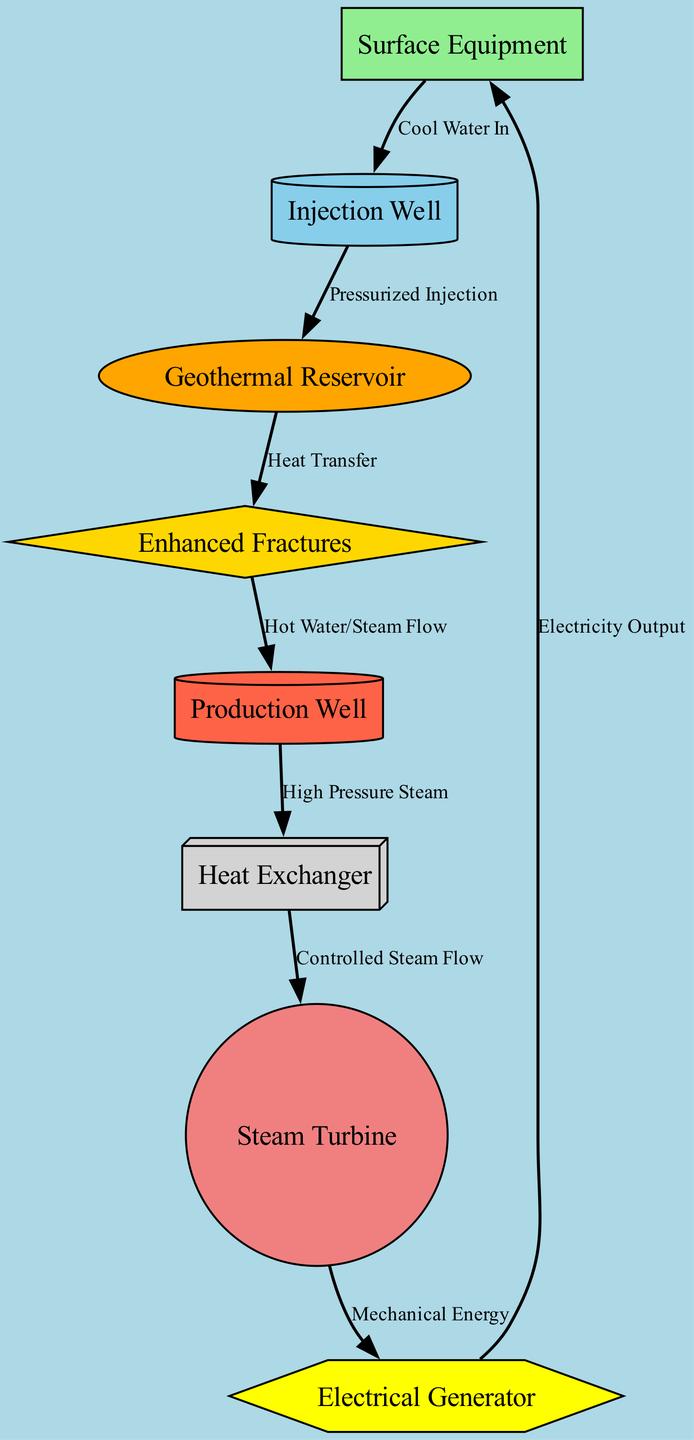What is the surface equipment labeled in the diagram? The diagram explicitly shows the node labeled "Surface Equipment," which represents the equipment located on the surface.
Answer: Surface Equipment How many nodes are present in the diagram? By counting the nodes listed (Surface Equipment, Injection Well, Production Well, Geothermal Reservoir, Enhanced Fractures, Heat Exchanger, Steam Turbine, Electrical Generator), we find there are a total of 8 nodes.
Answer: 8 What does the injection well connect to? The edge labeled "Pressurized Injection" directly connects the Injection Well node to the Geothermal Reservoir node, indicating this relationship.
Answer: Geothermal Reservoir What is the function of the heat exchanger as shown in the diagram? The heat exchanger is connected to the Production Well and the Steam Turbine by the edge labeled "Controlled Steam Flow," indicating its role in transferring heat to produce steam.
Answer: Heat Exchanger Which component generates electricity in the system? The Electrical Generator node receives "Mechanical Energy" from the Steam Turbine and produces "Electricity Output," thus making it the component responsible for electricity generation.
Answer: Electrical Generator What is the flow from the geothermal reservoir to the production well? The flow is indicated by the edge labeled "Hot Water/Steam Flow," which moves from the Geothermal Reservoir to the Production Well node, representing the transfer of hot fluids.
Answer: Hot Water/Steam Flow What type of energy does the turbine convert? The turbine receives "Controlled Steam Flow" from the Heat Exchanger, and converts this into "Mechanical Energy" as illustrated in the edge connecting these two nodes.
Answer: Mechanical Energy What is the first action performed in the geothermal energy extraction process according to the diagram? The first action is indicated by the edge "Cool Water In" from the Surface Equipment to the Injection Well, which starts the process of injecting cool water into the system.
Answer: Cool Water In What is the role of enhanced fractures in the geothermal system? The Enhanced Fractures serve as pathways for heat transfer from the Geothermal Reservoir to the Production Well, as shown by the edge labeled "Heat Transfer."
Answer: Heat Transfer 